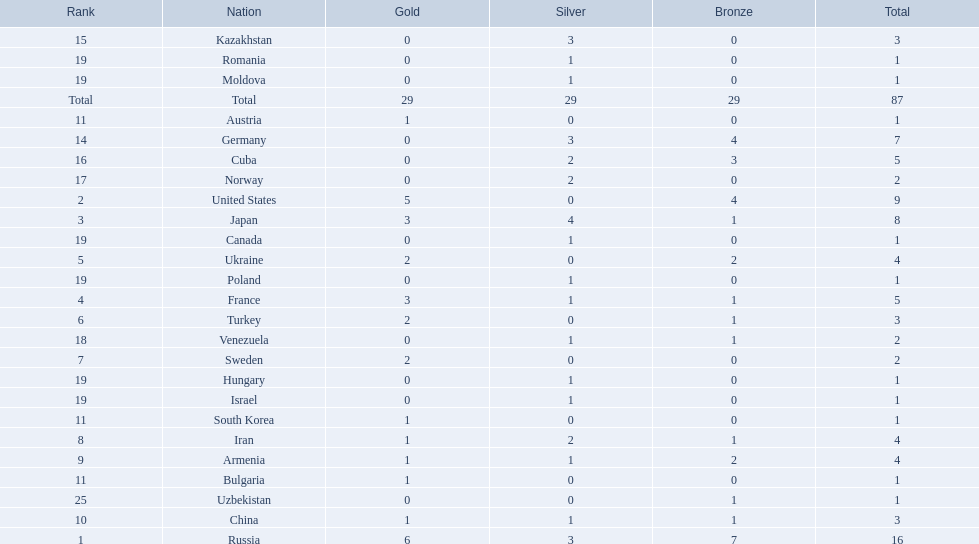Which nations have gold medals? Russia, United States, Japan, France, Ukraine, Turkey, Sweden, Iran, Armenia, China, Austria, Bulgaria, South Korea. Of those nations, which have only one gold medal? Iran, Armenia, China, Austria, Bulgaria, South Korea. Of those nations, which has no bronze or silver medals? Austria. 